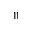<formula> <loc_0><loc_0><loc_500><loc_500>^ { 1 1 }</formula> 